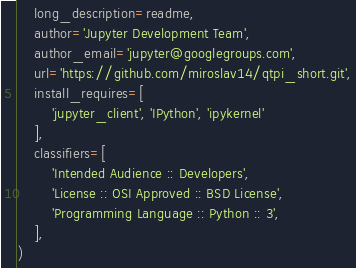<code> <loc_0><loc_0><loc_500><loc_500><_Python_>    long_description=readme,
    author='Jupyter Development Team',
    author_email='jupyter@googlegroups.com',
    url='https://github.com/miroslav14/qtpi_short.git',
    install_requires=[
        'jupyter_client', 'IPython', 'ipykernel'
    ],
    classifiers=[
        'Intended Audience :: Developers',
        'License :: OSI Approved :: BSD License',
        'Programming Language :: Python :: 3',
    ],
)
</code> 